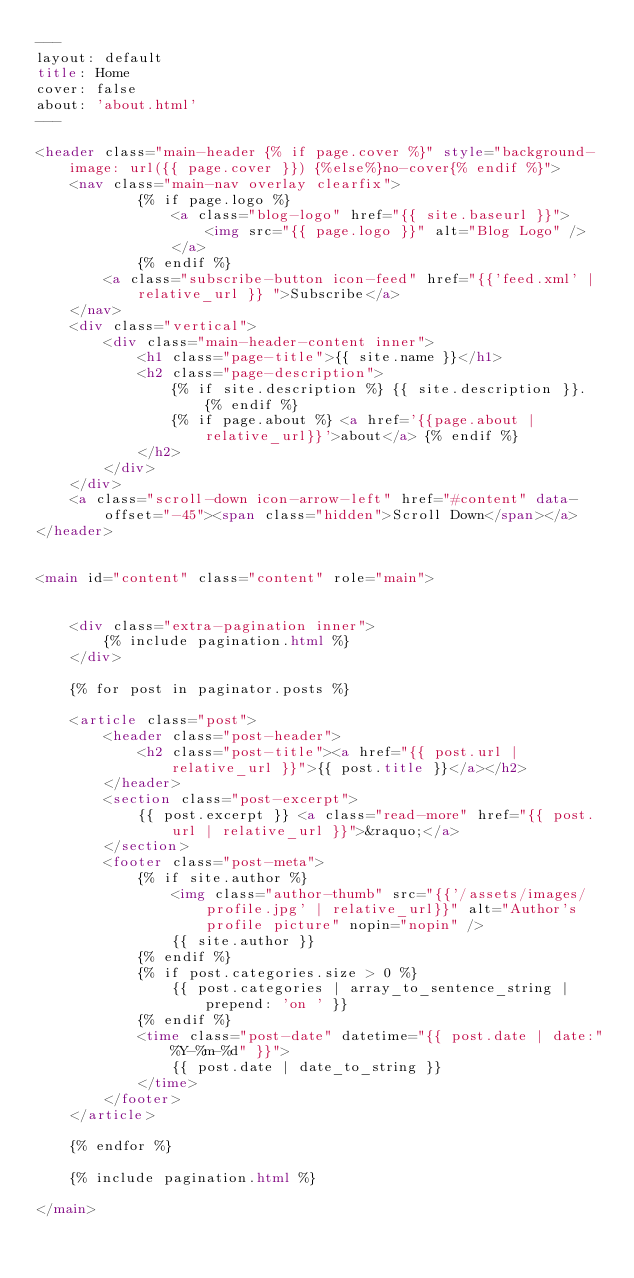<code> <loc_0><loc_0><loc_500><loc_500><_HTML_>---
layout: default
title: Home
cover: false
about: 'about.html'
---

<header class="main-header {% if page.cover %}" style="background-image: url({{ page.cover }}) {%else%}no-cover{% endif %}">
    <nav class="main-nav overlay clearfix">
            {% if page.logo %}
                <a class="blog-logo" href="{{ site.baseurl }}">
                    <img src="{{ page.logo }}" alt="Blog Logo" />
                </a>
            {% endif %}
        <a class="subscribe-button icon-feed" href="{{'feed.xml' | relative_url }} ">Subscribe</a>
    </nav>
    <div class="vertical">
        <div class="main-header-content inner">
            <h1 class="page-title">{{ site.name }}</h1>
            <h2 class="page-description">
                {% if site.description %} {{ site.description }}. {% endif %}
                {% if page.about %} <a href='{{page.about | relative_url}}'>about</a> {% endif %}
            </h2>
        </div>
    </div>
    <a class="scroll-down icon-arrow-left" href="#content" data-offset="-45"><span class="hidden">Scroll Down</span></a>
</header>


<main id="content" class="content" role="main">


    <div class="extra-pagination inner">
        {% include pagination.html %}
    </div>

    {% for post in paginator.posts %}

    <article class="post">
        <header class="post-header">
            <h2 class="post-title"><a href="{{ post.url | relative_url }}">{{ post.title }}</a></h2>
        </header>
        <section class="post-excerpt">
            {{ post.excerpt }} <a class="read-more" href="{{ post.url | relative_url }}">&raquo;</a>
        </section>
        <footer class="post-meta">
            {% if site.author %}
                <img class="author-thumb" src="{{'/assets/images/profile.jpg' | relative_url}}" alt="Author's profile picture" nopin="nopin" />
                {{ site.author }}
            {% endif %}
            {% if post.categories.size > 0 %} 
                {{ post.categories | array_to_sentence_string | prepend: 'on ' }} 
            {% endif %}
            <time class="post-date" datetime="{{ post.date | date:"%Y-%m-%d" }}">
                {{ post.date | date_to_string }}
            </time> 
        </footer>
    </article>

    {% endfor %}

    {% include pagination.html %}

</main>
</code> 